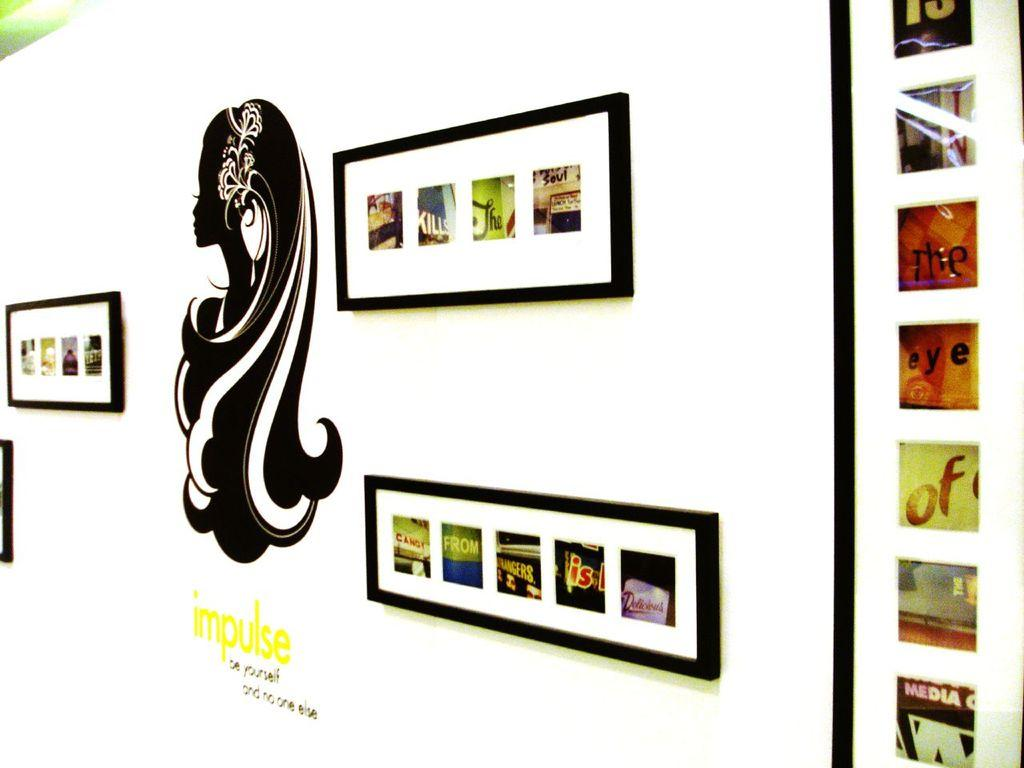<image>
Relay a brief, clear account of the picture shown. Art pieces on a wall with the word impulse in yellow writing. 